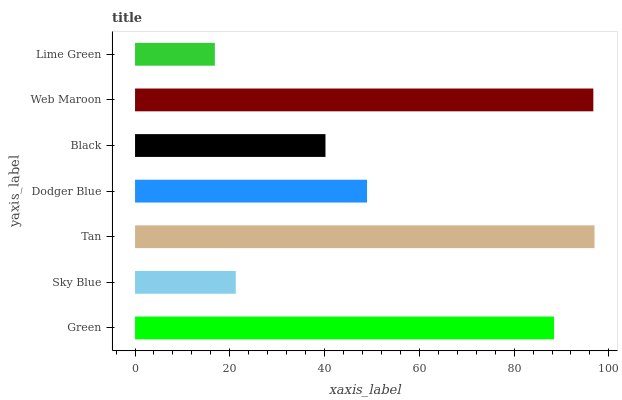Is Lime Green the minimum?
Answer yes or no. Yes. Is Tan the maximum?
Answer yes or no. Yes. Is Sky Blue the minimum?
Answer yes or no. No. Is Sky Blue the maximum?
Answer yes or no. No. Is Green greater than Sky Blue?
Answer yes or no. Yes. Is Sky Blue less than Green?
Answer yes or no. Yes. Is Sky Blue greater than Green?
Answer yes or no. No. Is Green less than Sky Blue?
Answer yes or no. No. Is Dodger Blue the high median?
Answer yes or no. Yes. Is Dodger Blue the low median?
Answer yes or no. Yes. Is Sky Blue the high median?
Answer yes or no. No. Is Tan the low median?
Answer yes or no. No. 